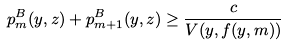<formula> <loc_0><loc_0><loc_500><loc_500>p _ { m } ^ { B } ( y , z ) + p _ { m + 1 } ^ { B } ( y , z ) \geq \frac { c } { V ( y , f ( y , m ) ) }</formula> 